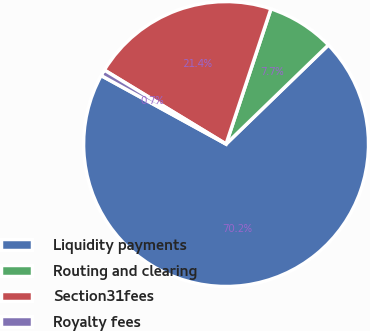Convert chart. <chart><loc_0><loc_0><loc_500><loc_500><pie_chart><fcel>Liquidity payments<fcel>Routing and clearing<fcel>Section31fees<fcel>Royalty fees<nl><fcel>70.22%<fcel>7.66%<fcel>21.41%<fcel>0.71%<nl></chart> 